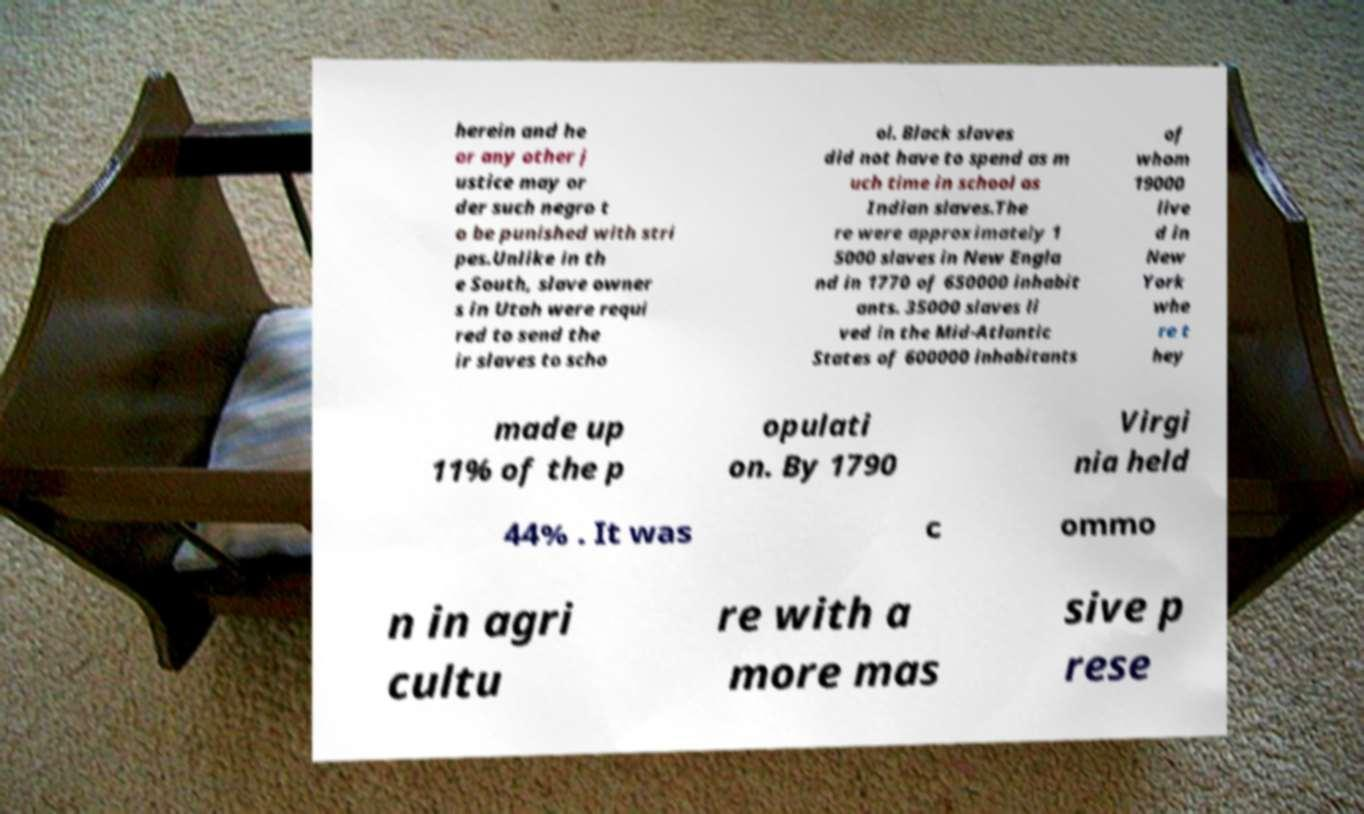For documentation purposes, I need the text within this image transcribed. Could you provide that? herein and he or any other j ustice may or der such negro t o be punished with stri pes.Unlike in th e South, slave owner s in Utah were requi red to send the ir slaves to scho ol. Black slaves did not have to spend as m uch time in school as Indian slaves.The re were approximately 1 5000 slaves in New Engla nd in 1770 of 650000 inhabit ants. 35000 slaves li ved in the Mid-Atlantic States of 600000 inhabitants of whom 19000 live d in New York whe re t hey made up 11% of the p opulati on. By 1790 Virgi nia held 44% . It was c ommo n in agri cultu re with a more mas sive p rese 